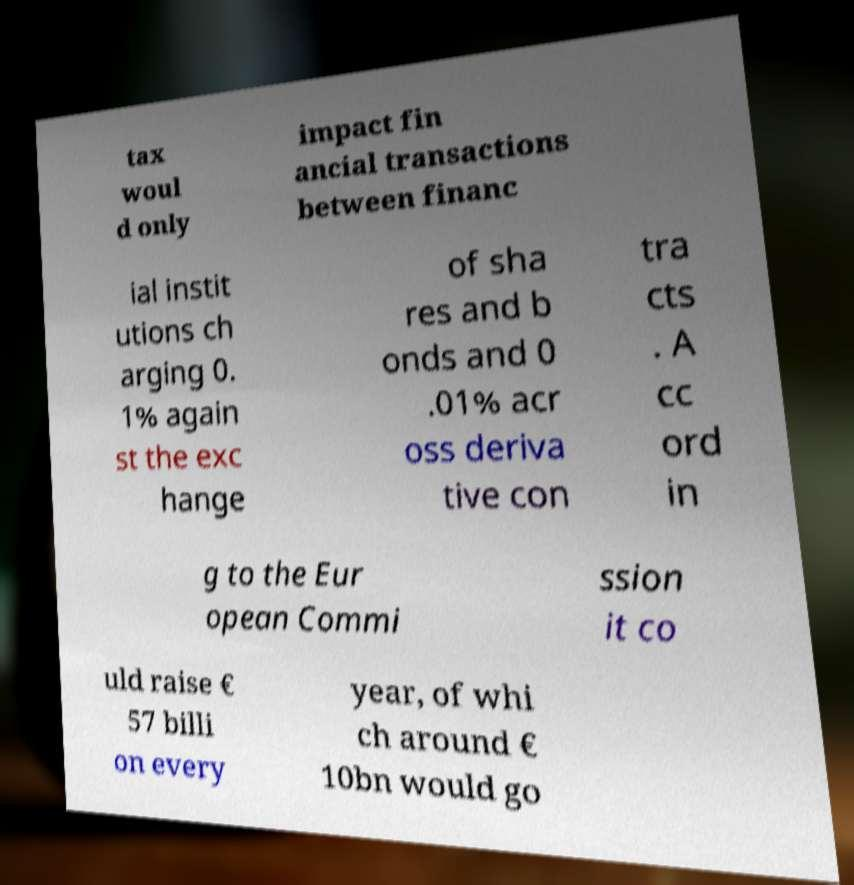For documentation purposes, I need the text within this image transcribed. Could you provide that? tax woul d only impact fin ancial transactions between financ ial instit utions ch arging 0. 1% again st the exc hange of sha res and b onds and 0 .01% acr oss deriva tive con tra cts . A cc ord in g to the Eur opean Commi ssion it co uld raise € 57 billi on every year, of whi ch around € 10bn would go 